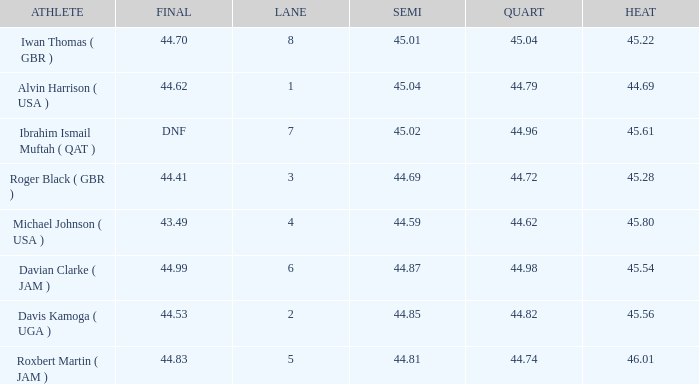When a lane of 4 has a QUART greater than 44.62, what is the lowest HEAT? None. 